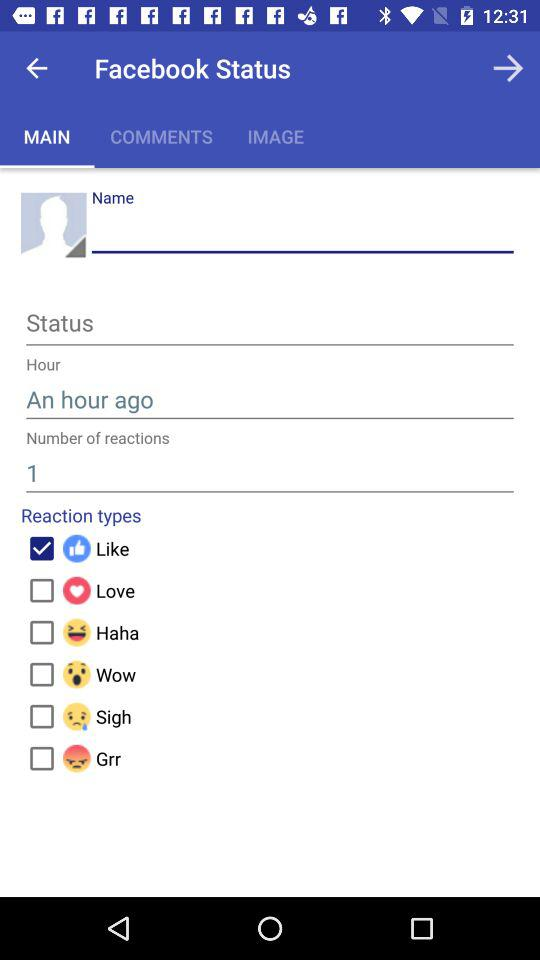Which tab am I on? You are on the "MAIN" tab. 